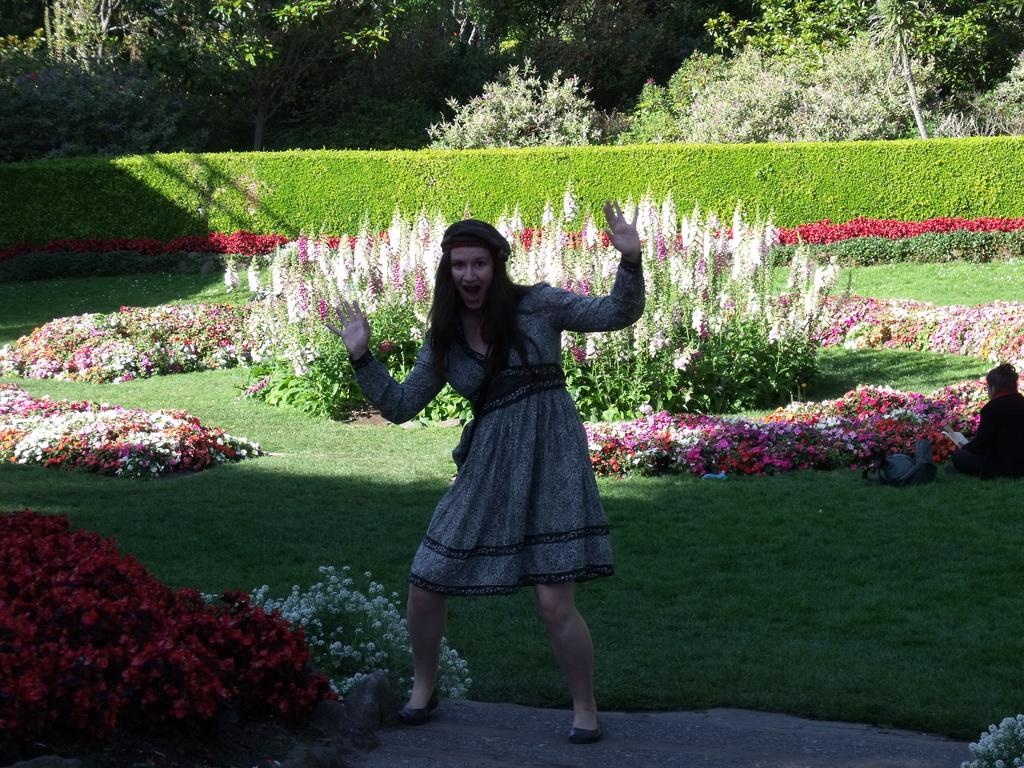What is the main subject of the image? There is a woman standing in the image. What is the woman standing on? The woman is standing on a floor. What can be seen in the background of the image? There is a garden in the background of the image. What types of plants are present in the garden? The garden contains flower plants and trees. Are there any other people in the image besides the standing woman? Yes, there is a woman sitting in the garden. What is the birth date of the woman standing in the image? There is no information about the woman's birth date in the image. What show is the woman standing in the image promoting? There is no indication of a show or promotion in the image. 